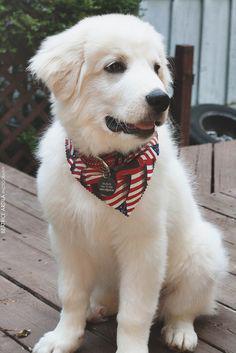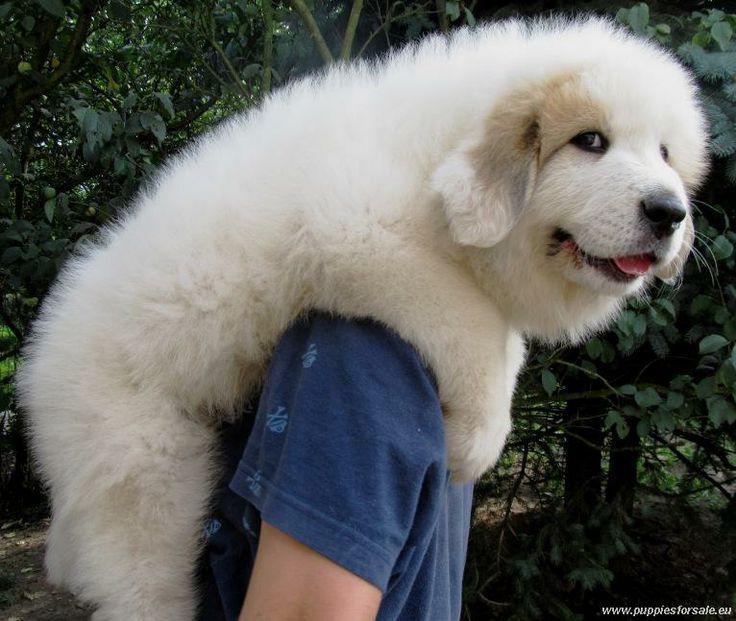The first image is the image on the left, the second image is the image on the right. For the images shown, is this caption "An image shows a toddler next to a sitting white dog." true? Answer yes or no. No. 